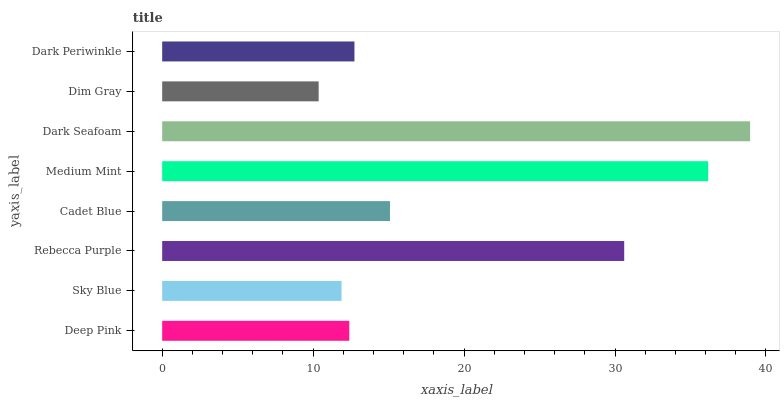Is Dim Gray the minimum?
Answer yes or no. Yes. Is Dark Seafoam the maximum?
Answer yes or no. Yes. Is Sky Blue the minimum?
Answer yes or no. No. Is Sky Blue the maximum?
Answer yes or no. No. Is Deep Pink greater than Sky Blue?
Answer yes or no. Yes. Is Sky Blue less than Deep Pink?
Answer yes or no. Yes. Is Sky Blue greater than Deep Pink?
Answer yes or no. No. Is Deep Pink less than Sky Blue?
Answer yes or no. No. Is Cadet Blue the high median?
Answer yes or no. Yes. Is Dark Periwinkle the low median?
Answer yes or no. Yes. Is Dim Gray the high median?
Answer yes or no. No. Is Medium Mint the low median?
Answer yes or no. No. 